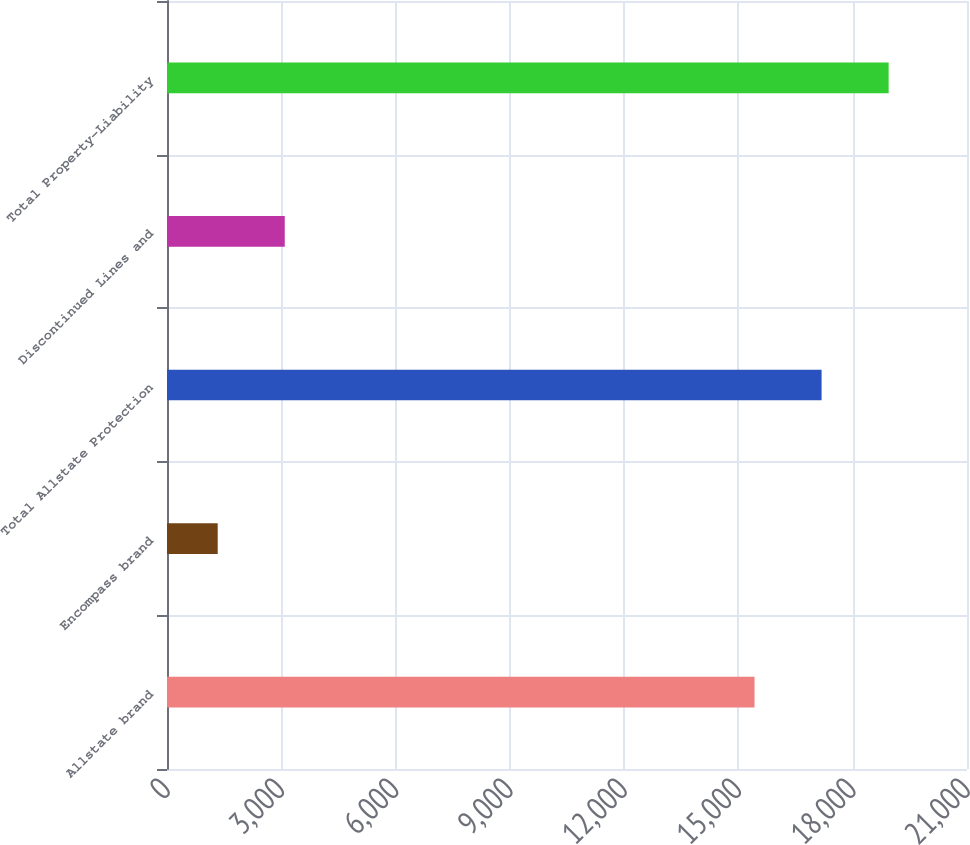Convert chart to OTSL. <chart><loc_0><loc_0><loc_500><loc_500><bar_chart><fcel>Allstate brand<fcel>Encompass brand<fcel>Total Allstate Protection<fcel>Discontinued Lines and<fcel>Total Property-Liability<nl><fcel>15423<fcel>1331<fcel>17183<fcel>3091<fcel>18943<nl></chart> 